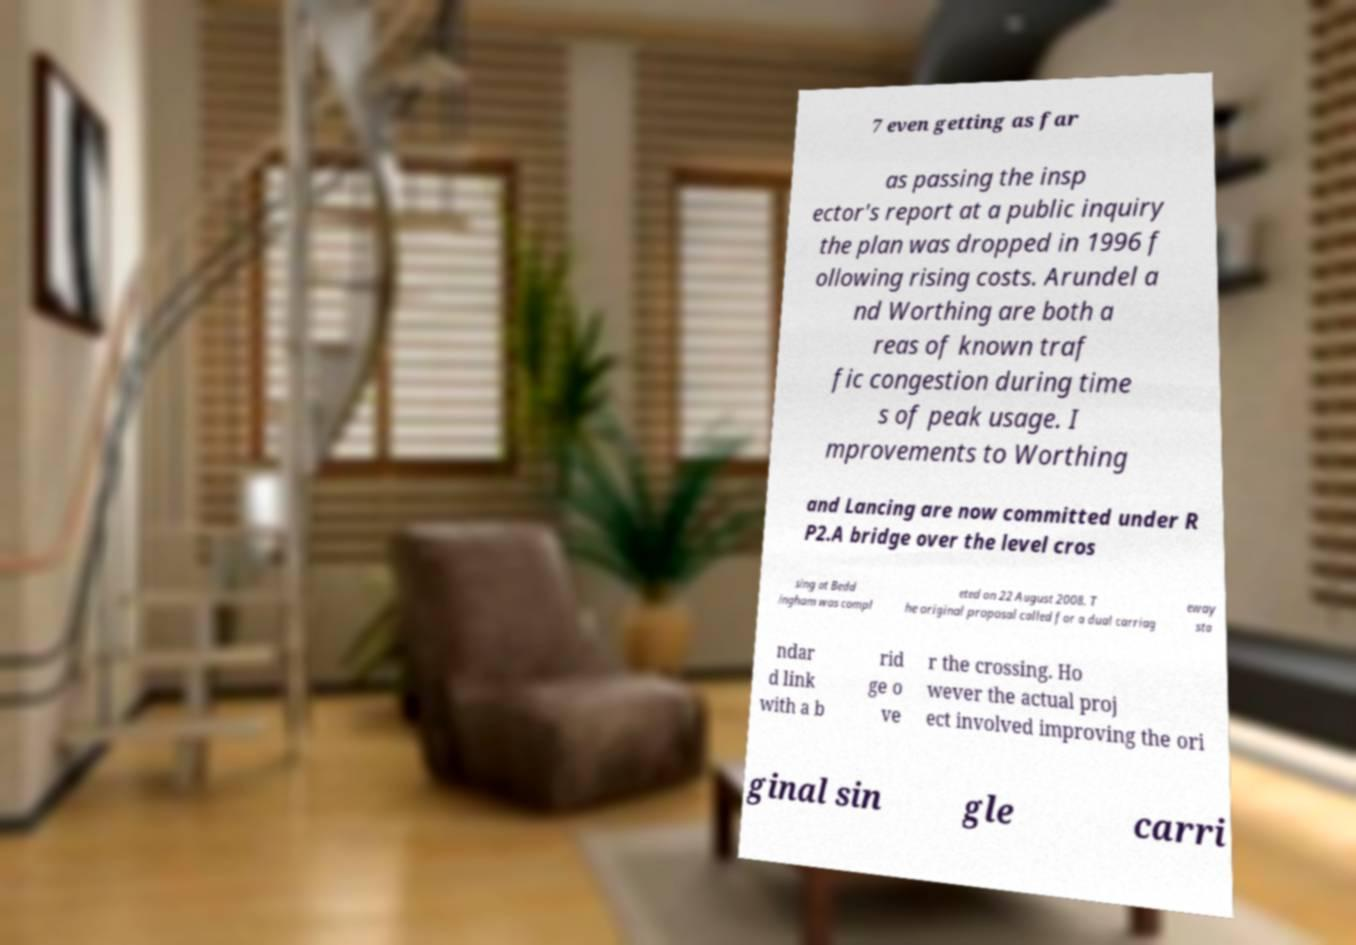For documentation purposes, I need the text within this image transcribed. Could you provide that? 7 even getting as far as passing the insp ector's report at a public inquiry the plan was dropped in 1996 f ollowing rising costs. Arundel a nd Worthing are both a reas of known traf fic congestion during time s of peak usage. I mprovements to Worthing and Lancing are now committed under R P2.A bridge over the level cros sing at Bedd ingham was compl eted on 22 August 2008. T he original proposal called for a dual carriag eway sta ndar d link with a b rid ge o ve r the crossing. Ho wever the actual proj ect involved improving the ori ginal sin gle carri 